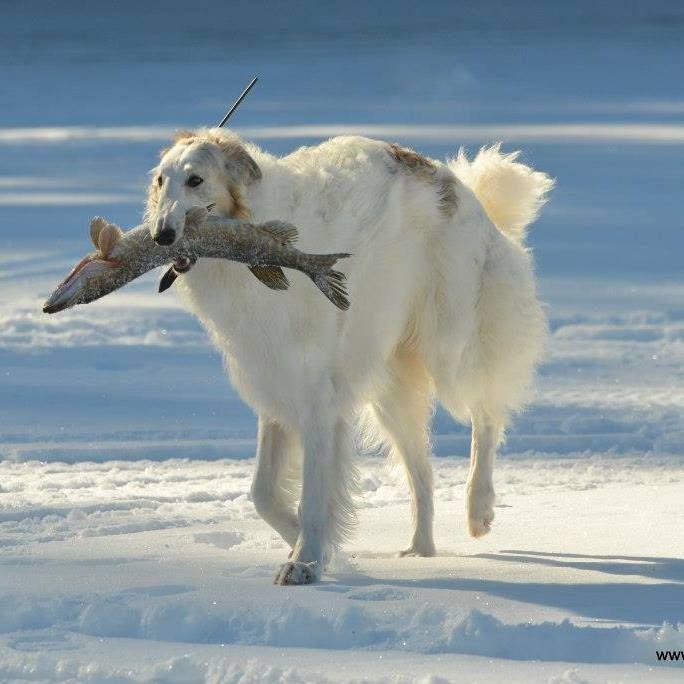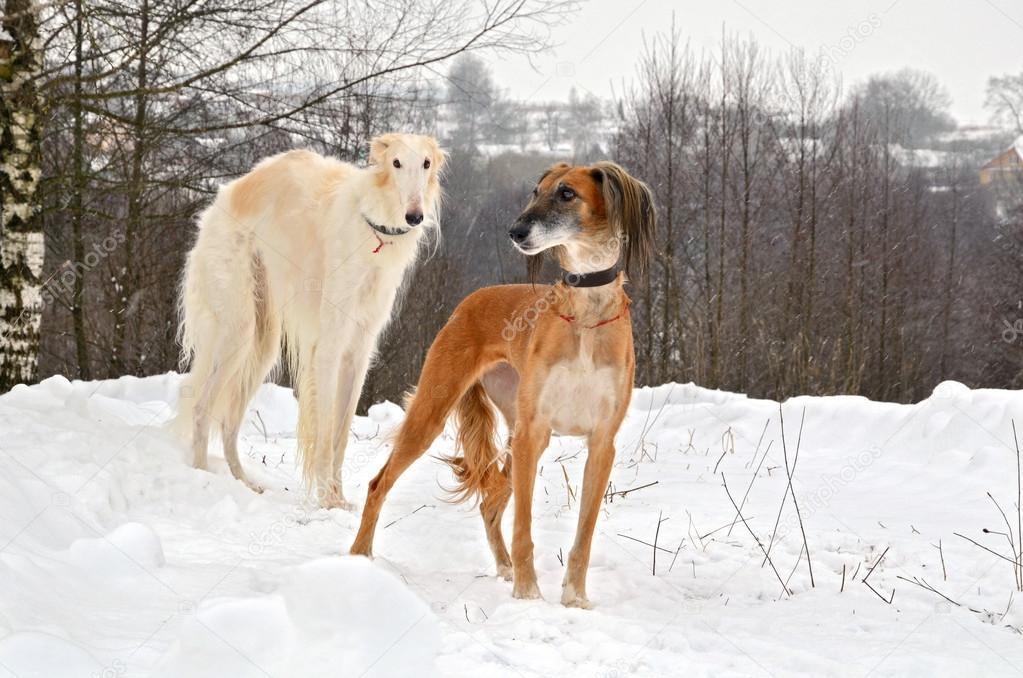The first image is the image on the left, the second image is the image on the right. Evaluate the accuracy of this statement regarding the images: "The dog in the image on the right is carrying something in its mouth.". Is it true? Answer yes or no. No. The first image is the image on the left, the second image is the image on the right. For the images displayed, is the sentence "A dog that is mostly orange and a dog that is mostly white are together in a field covered with snow." factually correct? Answer yes or no. Yes. 